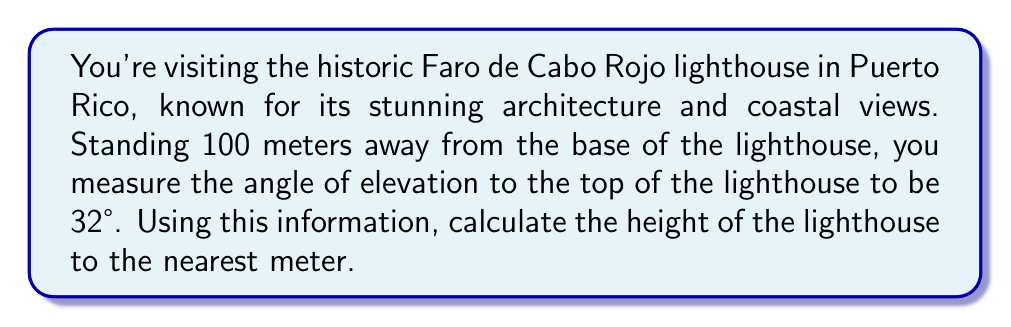What is the answer to this math problem? To solve this problem, we'll use the tangent trigonometric ratio. Let's break it down step-by-step:

1) First, let's visualize the problem:

[asy]
import geometry;

size(200);
pair A = (0,0), B = (100,0), C = (100,63);
draw(A--B--C--A);
label("100 m", (50,0), S);
label("h", (102,31.5), E);
label("32°", (5,5), NW);
draw(A--(5,0), arrow=Arrow(TeXHead));
draw((95,0)--C, arrow=Arrow(TeXHead));
[/asy]

2) In this right-angled triangle:
   - The adjacent side is the distance from you to the lighthouse (100 m)
   - The opposite side is the height of the lighthouse (h)
   - The angle of elevation is 32°

3) The tangent ratio is defined as:

   $$ \tan(\theta) = \frac{\text{opposite}}{\text{adjacent}} $$

4) Plugging in our values:

   $$ \tan(32°) = \frac{h}{100} $$

5) To solve for h, multiply both sides by 100:

   $$ h = 100 \cdot \tan(32°) $$

6) Using a calculator (or trigonometric tables):

   $$ h = 100 \cdot 0.6249 = 62.49 \text{ meters} $$

7) Rounding to the nearest meter:

   $$ h \approx 62 \text{ meters} $$

Thus, the height of the Faro de Cabo Rojo lighthouse is approximately 62 meters.
Answer: The height of the lighthouse is approximately 62 meters. 